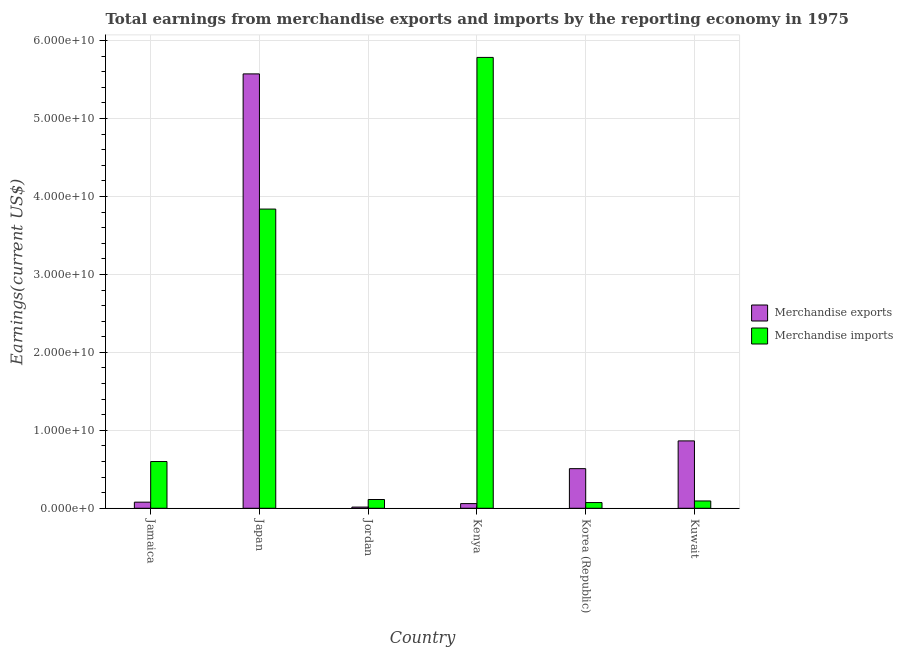Are the number of bars per tick equal to the number of legend labels?
Your response must be concise. Yes. Are the number of bars on each tick of the X-axis equal?
Offer a very short reply. Yes. How many bars are there on the 5th tick from the left?
Your answer should be very brief. 2. How many bars are there on the 2nd tick from the right?
Your answer should be very brief. 2. What is the label of the 1st group of bars from the left?
Keep it short and to the point. Jamaica. In how many cases, is the number of bars for a given country not equal to the number of legend labels?
Your response must be concise. 0. What is the earnings from merchandise exports in Japan?
Ensure brevity in your answer.  5.57e+1. Across all countries, what is the maximum earnings from merchandise imports?
Give a very brief answer. 5.78e+1. Across all countries, what is the minimum earnings from merchandise exports?
Offer a terse response. 1.53e+08. In which country was the earnings from merchandise imports minimum?
Your response must be concise. Korea (Republic). What is the total earnings from merchandise exports in the graph?
Offer a terse response. 7.10e+1. What is the difference between the earnings from merchandise imports in Japan and that in Korea (Republic)?
Provide a succinct answer. 3.77e+1. What is the difference between the earnings from merchandise exports in Japan and the earnings from merchandise imports in Jamaica?
Your response must be concise. 4.97e+1. What is the average earnings from merchandise exports per country?
Make the answer very short. 1.18e+1. What is the difference between the earnings from merchandise exports and earnings from merchandise imports in Korea (Republic)?
Offer a terse response. 4.35e+09. In how many countries, is the earnings from merchandise exports greater than 14000000000 US$?
Offer a terse response. 1. What is the ratio of the earnings from merchandise imports in Japan to that in Kenya?
Provide a short and direct response. 0.66. Is the earnings from merchandise imports in Jamaica less than that in Jordan?
Provide a succinct answer. No. Is the difference between the earnings from merchandise exports in Jamaica and Kuwait greater than the difference between the earnings from merchandise imports in Jamaica and Kuwait?
Your answer should be compact. No. What is the difference between the highest and the second highest earnings from merchandise imports?
Make the answer very short. 1.95e+1. What is the difference between the highest and the lowest earnings from merchandise imports?
Ensure brevity in your answer.  5.71e+1. What does the 1st bar from the left in Kuwait represents?
Provide a short and direct response. Merchandise exports. What does the 2nd bar from the right in Kuwait represents?
Offer a very short reply. Merchandise exports. How many bars are there?
Keep it short and to the point. 12. What is the difference between two consecutive major ticks on the Y-axis?
Provide a succinct answer. 1.00e+1. Does the graph contain any zero values?
Keep it short and to the point. No. Does the graph contain grids?
Offer a terse response. Yes. Where does the legend appear in the graph?
Keep it short and to the point. Center right. What is the title of the graph?
Provide a succinct answer. Total earnings from merchandise exports and imports by the reporting economy in 1975. Does "Sanitation services" appear as one of the legend labels in the graph?
Offer a very short reply. No. What is the label or title of the Y-axis?
Your answer should be compact. Earnings(current US$). What is the Earnings(current US$) in Merchandise exports in Jamaica?
Make the answer very short. 7.84e+08. What is the Earnings(current US$) in Merchandise imports in Jamaica?
Your answer should be compact. 6.00e+09. What is the Earnings(current US$) in Merchandise exports in Japan?
Provide a short and direct response. 5.57e+1. What is the Earnings(current US$) in Merchandise imports in Japan?
Keep it short and to the point. 3.84e+1. What is the Earnings(current US$) of Merchandise exports in Jordan?
Your answer should be compact. 1.53e+08. What is the Earnings(current US$) in Merchandise imports in Jordan?
Give a very brief answer. 1.12e+09. What is the Earnings(current US$) of Merchandise exports in Kenya?
Your answer should be very brief. 5.99e+08. What is the Earnings(current US$) of Merchandise imports in Kenya?
Ensure brevity in your answer.  5.78e+1. What is the Earnings(current US$) in Merchandise exports in Korea (Republic)?
Keep it short and to the point. 5.08e+09. What is the Earnings(current US$) of Merchandise imports in Korea (Republic)?
Offer a very short reply. 7.33e+08. What is the Earnings(current US$) of Merchandise exports in Kuwait?
Your answer should be compact. 8.64e+09. What is the Earnings(current US$) in Merchandise imports in Kuwait?
Ensure brevity in your answer.  9.39e+08. Across all countries, what is the maximum Earnings(current US$) in Merchandise exports?
Provide a succinct answer. 5.57e+1. Across all countries, what is the maximum Earnings(current US$) in Merchandise imports?
Your answer should be compact. 5.78e+1. Across all countries, what is the minimum Earnings(current US$) in Merchandise exports?
Provide a succinct answer. 1.53e+08. Across all countries, what is the minimum Earnings(current US$) in Merchandise imports?
Provide a short and direct response. 7.33e+08. What is the total Earnings(current US$) in Merchandise exports in the graph?
Provide a short and direct response. 7.10e+1. What is the total Earnings(current US$) in Merchandise imports in the graph?
Ensure brevity in your answer.  1.05e+11. What is the difference between the Earnings(current US$) of Merchandise exports in Jamaica and that in Japan?
Give a very brief answer. -5.50e+1. What is the difference between the Earnings(current US$) in Merchandise imports in Jamaica and that in Japan?
Your answer should be very brief. -3.24e+1. What is the difference between the Earnings(current US$) of Merchandise exports in Jamaica and that in Jordan?
Keep it short and to the point. 6.31e+08. What is the difference between the Earnings(current US$) in Merchandise imports in Jamaica and that in Jordan?
Offer a terse response. 4.87e+09. What is the difference between the Earnings(current US$) of Merchandise exports in Jamaica and that in Kenya?
Provide a succinct answer. 1.85e+08. What is the difference between the Earnings(current US$) in Merchandise imports in Jamaica and that in Kenya?
Give a very brief answer. -5.18e+1. What is the difference between the Earnings(current US$) in Merchandise exports in Jamaica and that in Korea (Republic)?
Your answer should be compact. -4.30e+09. What is the difference between the Earnings(current US$) in Merchandise imports in Jamaica and that in Korea (Republic)?
Your answer should be compact. 5.27e+09. What is the difference between the Earnings(current US$) of Merchandise exports in Jamaica and that in Kuwait?
Keep it short and to the point. -7.86e+09. What is the difference between the Earnings(current US$) in Merchandise imports in Jamaica and that in Kuwait?
Keep it short and to the point. 5.06e+09. What is the difference between the Earnings(current US$) of Merchandise exports in Japan and that in Jordan?
Your answer should be very brief. 5.56e+1. What is the difference between the Earnings(current US$) of Merchandise imports in Japan and that in Jordan?
Offer a terse response. 3.73e+1. What is the difference between the Earnings(current US$) in Merchandise exports in Japan and that in Kenya?
Offer a very short reply. 5.51e+1. What is the difference between the Earnings(current US$) in Merchandise imports in Japan and that in Kenya?
Offer a very short reply. -1.95e+1. What is the difference between the Earnings(current US$) in Merchandise exports in Japan and that in Korea (Republic)?
Your answer should be very brief. 5.07e+1. What is the difference between the Earnings(current US$) of Merchandise imports in Japan and that in Korea (Republic)?
Offer a very short reply. 3.77e+1. What is the difference between the Earnings(current US$) in Merchandise exports in Japan and that in Kuwait?
Provide a succinct answer. 4.71e+1. What is the difference between the Earnings(current US$) in Merchandise imports in Japan and that in Kuwait?
Your answer should be very brief. 3.75e+1. What is the difference between the Earnings(current US$) of Merchandise exports in Jordan and that in Kenya?
Your response must be concise. -4.46e+08. What is the difference between the Earnings(current US$) of Merchandise imports in Jordan and that in Kenya?
Offer a terse response. -5.67e+1. What is the difference between the Earnings(current US$) of Merchandise exports in Jordan and that in Korea (Republic)?
Keep it short and to the point. -4.93e+09. What is the difference between the Earnings(current US$) in Merchandise imports in Jordan and that in Korea (Republic)?
Offer a very short reply. 3.91e+08. What is the difference between the Earnings(current US$) of Merchandise exports in Jordan and that in Kuwait?
Your answer should be compact. -8.49e+09. What is the difference between the Earnings(current US$) in Merchandise imports in Jordan and that in Kuwait?
Ensure brevity in your answer.  1.85e+08. What is the difference between the Earnings(current US$) of Merchandise exports in Kenya and that in Korea (Republic)?
Your answer should be compact. -4.48e+09. What is the difference between the Earnings(current US$) of Merchandise imports in Kenya and that in Korea (Republic)?
Offer a terse response. 5.71e+1. What is the difference between the Earnings(current US$) in Merchandise exports in Kenya and that in Kuwait?
Your answer should be compact. -8.04e+09. What is the difference between the Earnings(current US$) of Merchandise imports in Kenya and that in Kuwait?
Your response must be concise. 5.69e+1. What is the difference between the Earnings(current US$) in Merchandise exports in Korea (Republic) and that in Kuwait?
Provide a short and direct response. -3.56e+09. What is the difference between the Earnings(current US$) of Merchandise imports in Korea (Republic) and that in Kuwait?
Give a very brief answer. -2.06e+08. What is the difference between the Earnings(current US$) in Merchandise exports in Jamaica and the Earnings(current US$) in Merchandise imports in Japan?
Make the answer very short. -3.76e+1. What is the difference between the Earnings(current US$) of Merchandise exports in Jamaica and the Earnings(current US$) of Merchandise imports in Jordan?
Keep it short and to the point. -3.40e+08. What is the difference between the Earnings(current US$) in Merchandise exports in Jamaica and the Earnings(current US$) in Merchandise imports in Kenya?
Give a very brief answer. -5.71e+1. What is the difference between the Earnings(current US$) of Merchandise exports in Jamaica and the Earnings(current US$) of Merchandise imports in Korea (Republic)?
Provide a succinct answer. 5.13e+07. What is the difference between the Earnings(current US$) in Merchandise exports in Jamaica and the Earnings(current US$) in Merchandise imports in Kuwait?
Give a very brief answer. -1.55e+08. What is the difference between the Earnings(current US$) of Merchandise exports in Japan and the Earnings(current US$) of Merchandise imports in Jordan?
Offer a very short reply. 5.46e+1. What is the difference between the Earnings(current US$) of Merchandise exports in Japan and the Earnings(current US$) of Merchandise imports in Kenya?
Provide a short and direct response. -2.11e+09. What is the difference between the Earnings(current US$) of Merchandise exports in Japan and the Earnings(current US$) of Merchandise imports in Korea (Republic)?
Offer a very short reply. 5.50e+1. What is the difference between the Earnings(current US$) of Merchandise exports in Japan and the Earnings(current US$) of Merchandise imports in Kuwait?
Your response must be concise. 5.48e+1. What is the difference between the Earnings(current US$) of Merchandise exports in Jordan and the Earnings(current US$) of Merchandise imports in Kenya?
Your response must be concise. -5.77e+1. What is the difference between the Earnings(current US$) of Merchandise exports in Jordan and the Earnings(current US$) of Merchandise imports in Korea (Republic)?
Ensure brevity in your answer.  -5.80e+08. What is the difference between the Earnings(current US$) of Merchandise exports in Jordan and the Earnings(current US$) of Merchandise imports in Kuwait?
Keep it short and to the point. -7.86e+08. What is the difference between the Earnings(current US$) in Merchandise exports in Kenya and the Earnings(current US$) in Merchandise imports in Korea (Republic)?
Your response must be concise. -1.34e+08. What is the difference between the Earnings(current US$) of Merchandise exports in Kenya and the Earnings(current US$) of Merchandise imports in Kuwait?
Offer a terse response. -3.40e+08. What is the difference between the Earnings(current US$) of Merchandise exports in Korea (Republic) and the Earnings(current US$) of Merchandise imports in Kuwait?
Your answer should be compact. 4.15e+09. What is the average Earnings(current US$) of Merchandise exports per country?
Offer a terse response. 1.18e+1. What is the average Earnings(current US$) of Merchandise imports per country?
Offer a terse response. 1.75e+1. What is the difference between the Earnings(current US$) of Merchandise exports and Earnings(current US$) of Merchandise imports in Jamaica?
Your answer should be compact. -5.21e+09. What is the difference between the Earnings(current US$) in Merchandise exports and Earnings(current US$) in Merchandise imports in Japan?
Ensure brevity in your answer.  1.73e+1. What is the difference between the Earnings(current US$) of Merchandise exports and Earnings(current US$) of Merchandise imports in Jordan?
Your answer should be compact. -9.71e+08. What is the difference between the Earnings(current US$) in Merchandise exports and Earnings(current US$) in Merchandise imports in Kenya?
Give a very brief answer. -5.72e+1. What is the difference between the Earnings(current US$) in Merchandise exports and Earnings(current US$) in Merchandise imports in Korea (Republic)?
Give a very brief answer. 4.35e+09. What is the difference between the Earnings(current US$) in Merchandise exports and Earnings(current US$) in Merchandise imports in Kuwait?
Provide a succinct answer. 7.71e+09. What is the ratio of the Earnings(current US$) of Merchandise exports in Jamaica to that in Japan?
Your response must be concise. 0.01. What is the ratio of the Earnings(current US$) in Merchandise imports in Jamaica to that in Japan?
Provide a succinct answer. 0.16. What is the ratio of the Earnings(current US$) in Merchandise exports in Jamaica to that in Jordan?
Offer a terse response. 5.14. What is the ratio of the Earnings(current US$) in Merchandise imports in Jamaica to that in Jordan?
Your response must be concise. 5.34. What is the ratio of the Earnings(current US$) of Merchandise exports in Jamaica to that in Kenya?
Provide a succinct answer. 1.31. What is the ratio of the Earnings(current US$) of Merchandise imports in Jamaica to that in Kenya?
Your response must be concise. 0.1. What is the ratio of the Earnings(current US$) of Merchandise exports in Jamaica to that in Korea (Republic)?
Offer a terse response. 0.15. What is the ratio of the Earnings(current US$) of Merchandise imports in Jamaica to that in Korea (Republic)?
Offer a terse response. 8.19. What is the ratio of the Earnings(current US$) in Merchandise exports in Jamaica to that in Kuwait?
Give a very brief answer. 0.09. What is the ratio of the Earnings(current US$) of Merchandise imports in Jamaica to that in Kuwait?
Give a very brief answer. 6.39. What is the ratio of the Earnings(current US$) of Merchandise exports in Japan to that in Jordan?
Offer a very short reply. 365.23. What is the ratio of the Earnings(current US$) in Merchandise imports in Japan to that in Jordan?
Your response must be concise. 34.15. What is the ratio of the Earnings(current US$) in Merchandise exports in Japan to that in Kenya?
Give a very brief answer. 93.04. What is the ratio of the Earnings(current US$) in Merchandise imports in Japan to that in Kenya?
Provide a short and direct response. 0.66. What is the ratio of the Earnings(current US$) in Merchandise exports in Japan to that in Korea (Republic)?
Make the answer very short. 10.96. What is the ratio of the Earnings(current US$) in Merchandise imports in Japan to that in Korea (Republic)?
Ensure brevity in your answer.  52.4. What is the ratio of the Earnings(current US$) of Merchandise exports in Japan to that in Kuwait?
Provide a short and direct response. 6.45. What is the ratio of the Earnings(current US$) of Merchandise imports in Japan to that in Kuwait?
Offer a terse response. 40.9. What is the ratio of the Earnings(current US$) of Merchandise exports in Jordan to that in Kenya?
Offer a terse response. 0.25. What is the ratio of the Earnings(current US$) in Merchandise imports in Jordan to that in Kenya?
Provide a succinct answer. 0.02. What is the ratio of the Earnings(current US$) in Merchandise imports in Jordan to that in Korea (Republic)?
Keep it short and to the point. 1.53. What is the ratio of the Earnings(current US$) in Merchandise exports in Jordan to that in Kuwait?
Your answer should be compact. 0.02. What is the ratio of the Earnings(current US$) of Merchandise imports in Jordan to that in Kuwait?
Ensure brevity in your answer.  1.2. What is the ratio of the Earnings(current US$) of Merchandise exports in Kenya to that in Korea (Republic)?
Your answer should be compact. 0.12. What is the ratio of the Earnings(current US$) in Merchandise imports in Kenya to that in Korea (Republic)?
Offer a very short reply. 78.96. What is the ratio of the Earnings(current US$) in Merchandise exports in Kenya to that in Kuwait?
Keep it short and to the point. 0.07. What is the ratio of the Earnings(current US$) of Merchandise imports in Kenya to that in Kuwait?
Make the answer very short. 61.63. What is the ratio of the Earnings(current US$) in Merchandise exports in Korea (Republic) to that in Kuwait?
Provide a succinct answer. 0.59. What is the ratio of the Earnings(current US$) in Merchandise imports in Korea (Republic) to that in Kuwait?
Make the answer very short. 0.78. What is the difference between the highest and the second highest Earnings(current US$) of Merchandise exports?
Offer a terse response. 4.71e+1. What is the difference between the highest and the second highest Earnings(current US$) in Merchandise imports?
Make the answer very short. 1.95e+1. What is the difference between the highest and the lowest Earnings(current US$) in Merchandise exports?
Give a very brief answer. 5.56e+1. What is the difference between the highest and the lowest Earnings(current US$) in Merchandise imports?
Your response must be concise. 5.71e+1. 